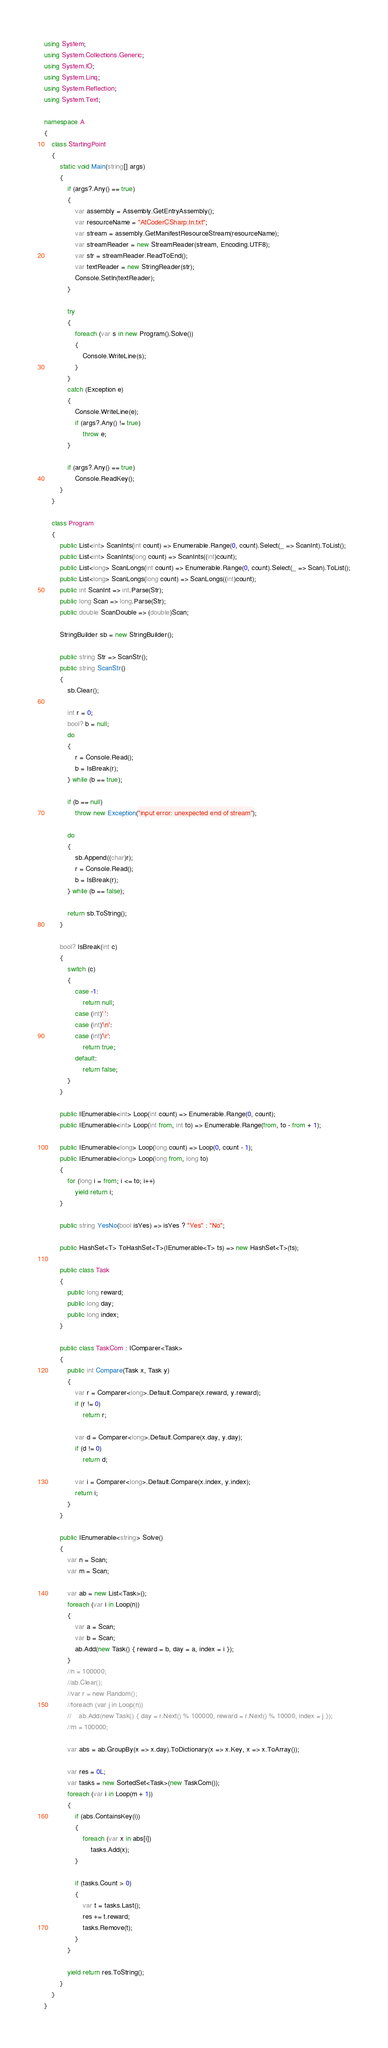Convert code to text. <code><loc_0><loc_0><loc_500><loc_500><_C#_>using System;
using System.Collections.Generic;
using System.IO;
using System.Linq;
using System.Reflection;
using System.Text;

namespace A
{
    class StartingPoint
    {
        static void Main(string[] args)
        {
            if (args?.Any() == true)
            {
                var assembly = Assembly.GetEntryAssembly();
                var resourceName = "AtCoderCSharp.In.txt";
                var stream = assembly.GetManifestResourceStream(resourceName);
                var streamReader = new StreamReader(stream, Encoding.UTF8);
                var str = streamReader.ReadToEnd();
                var textReader = new StringReader(str);
                Console.SetIn(textReader);
            }

            try
            {
                foreach (var s in new Program().Solve())
                {
                    Console.WriteLine(s);
                }
            }
            catch (Exception e)
            {
                Console.WriteLine(e);
                if (args?.Any() != true)
                    throw e;
            }

            if (args?.Any() == true)
                Console.ReadKey();
        }
    }

    class Program
    {
        public List<int> ScanInts(int count) => Enumerable.Range(0, count).Select(_ => ScanInt).ToList();
        public List<int> ScanInts(long count) => ScanInts((int)count);
        public List<long> ScanLongs(int count) => Enumerable.Range(0, count).Select(_ => Scan).ToList();
        public List<long> ScanLongs(long count) => ScanLongs((int)count);
        public int ScanInt => int.Parse(Str);
        public long Scan => long.Parse(Str);
        public double ScanDouble => (double)Scan;

        StringBuilder sb = new StringBuilder();

        public string Str => ScanStr();
        public string ScanStr()
        {
            sb.Clear();

            int r = 0;
            bool? b = null;
            do
            {
                r = Console.Read();
                b = IsBreak(r);
            } while (b == true);

            if (b == null)
                throw new Exception("input error: unexpected end of stream");

            do
            {
                sb.Append((char)r);
                r = Console.Read();
                b = IsBreak(r);
            } while (b == false);

            return sb.ToString();
        }

        bool? IsBreak(int c)
        {
            switch (c)
            {
                case -1:
                    return null;
                case (int)' ':
                case (int)'\n':
                case (int)'\r':
                    return true;
                default:
                    return false;
            }
        }

        public IEnumerable<int> Loop(int count) => Enumerable.Range(0, count);
        public IEnumerable<int> Loop(int from, int to) => Enumerable.Range(from, to - from + 1);

        public IEnumerable<long> Loop(long count) => Loop(0, count - 1);
        public IEnumerable<long> Loop(long from, long to)
        {
            for (long i = from; i <= to; i++)
                yield return i;
        }

        public string YesNo(bool isYes) => isYes ? "Yes" : "No";

        public HashSet<T> ToHashSet<T>(IEnumerable<T> ts) => new HashSet<T>(ts);

        public class Task
        {
            public long reward;
            public long day;
            public long index;
        }

        public class TaskCom : IComparer<Task>
        {
            public int Compare(Task x, Task y)
            {
                var r = Comparer<long>.Default.Compare(x.reward, y.reward);
                if (r != 0)
                    return r;

                var d = Comparer<long>.Default.Compare(x.day, y.day);
                if (d != 0)
                    return d;

                var i = Comparer<long>.Default.Compare(x.index, y.index);
                return i;
            }
        }

        public IEnumerable<string> Solve()
        {
            var n = Scan;
            var m = Scan;

            var ab = new List<Task>();
            foreach (var i in Loop(n))
            {
                var a = Scan;
                var b = Scan;
                ab.Add(new Task() { reward = b, day = a, index = i });
            }
            //n = 100000;
            //ab.Clear();
            //var r = new Random();
            //foreach (var j in Loop(n))
            //    ab.Add(new Task() { day = r.Next() % 100000, reward = r.Next() % 10000, index = j });
            //m = 100000;

            var abs = ab.GroupBy(x => x.day).ToDictionary(x => x.Key, x => x.ToArray());

            var res = 0L;
            var tasks = new SortedSet<Task>(new TaskCom());
            foreach (var i in Loop(m + 1))
            {
                if (abs.ContainsKey(i))
                {
                    foreach (var x in abs[i])
                        tasks.Add(x);
                }

                if (tasks.Count > 0)
                {
                    var t = tasks.Last();
                    res += t.reward;
                    tasks.Remove(t);
                }
            }

            yield return res.ToString();
        }
    }
}</code> 